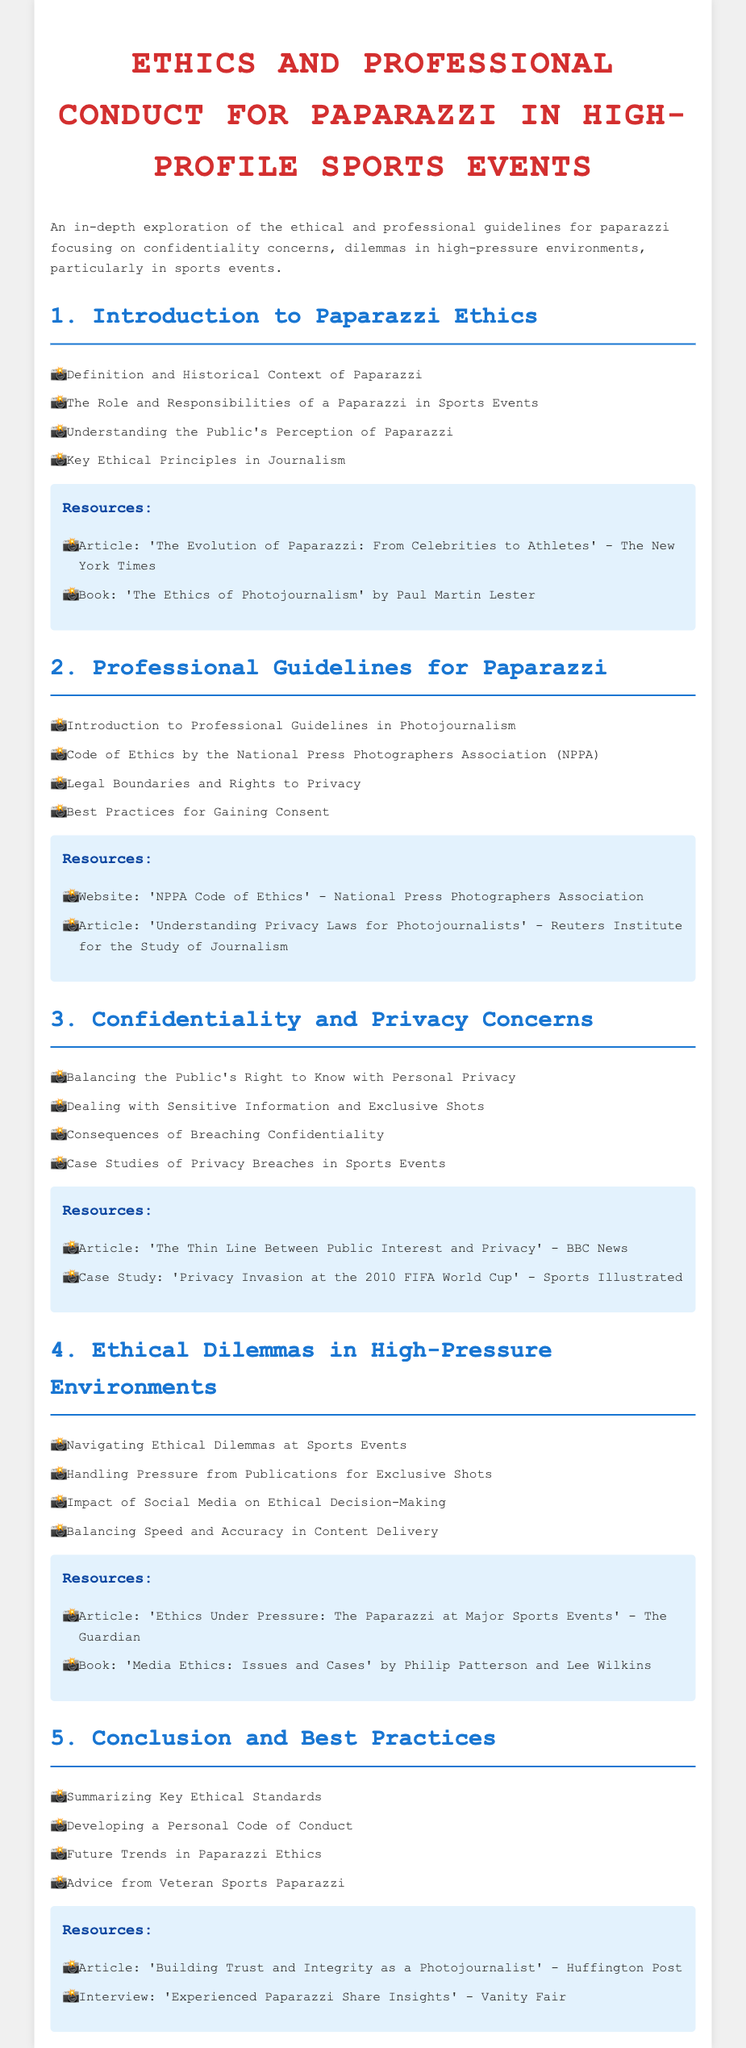What is the title of the syllabus? The title is clearly stated at the beginning of the document.
Answer: Ethics and Professional Conduct for Paparazzi in High-Profile Sports Events Who is the author of the book mentioned in the resources for ethics of photojournalism? The author’s name is provided in the document associated with a specific book resource.
Answer: Paul Martin Lester What year does the case study 'Privacy Invasion at the 2010 FIFA World Cup' relate to? The case study title indicates a specific event with its corresponding year.
Answer: 2010 Which organization’s Code of Ethics is referenced in the professional guidelines? The document mentions an organization that establishes ethical standards for photographers.
Answer: National Press Photographers Association In which section would you find resources about handling pressure from publications? The section details ethical dilemmas and practical challenges faced by paparazzi at events.
Answer: Ethical Dilemmas in High-Pressure Environments How many main sections does the syllabus contain? The document lists the major headings to facilitate navigation through its content.
Answer: Five What is the focus of the third section of the syllabus? The title of the section provides insight into its thematic concern related to personal boundaries and ethical practices.
Answer: Confidentiality and Privacy Concerns What type of skills are discussed in the fifth section? The conclusion section highlights the skills aimed at improving professional conduct among paparazzi.
Answer: Best Practices What publication discussed 'Ethics Under Pressure'? This specific article is listed as a resource for further exploration of ethical considerations in high-stakes environments.
Answer: The Guardian 